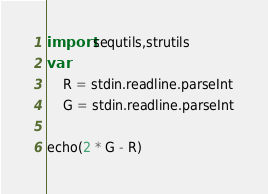<code> <loc_0><loc_0><loc_500><loc_500><_Nim_>import sequtils,strutils
var
    R = stdin.readline.parseInt
    G = stdin.readline.parseInt

echo(2 * G - R)</code> 